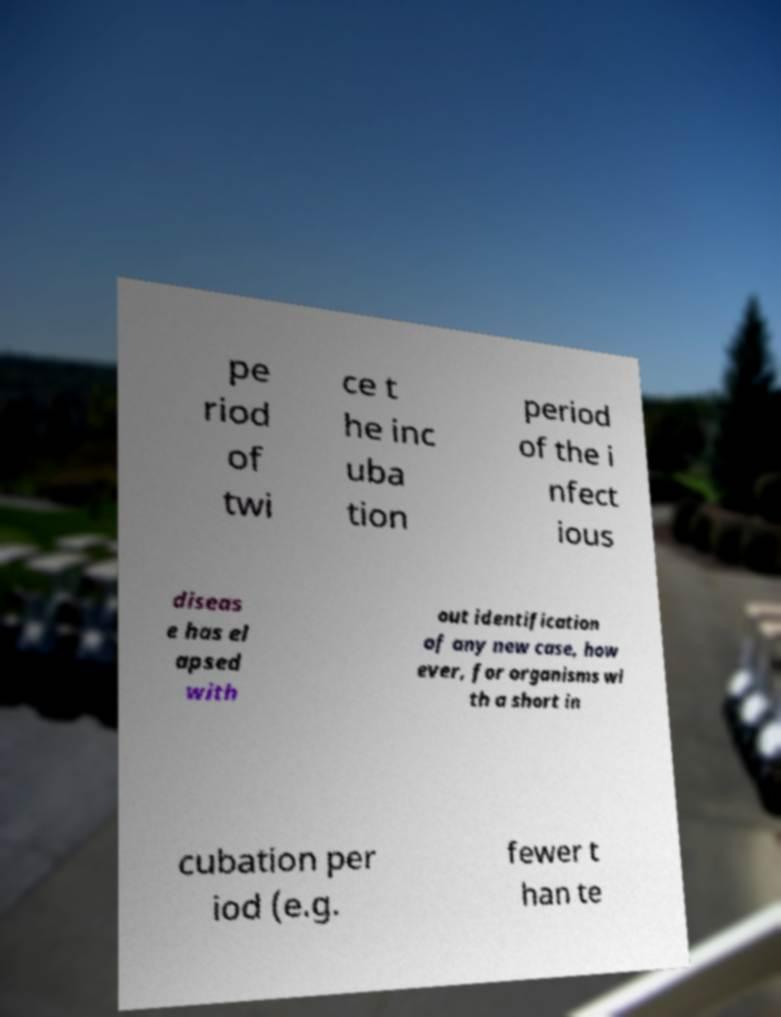There's text embedded in this image that I need extracted. Can you transcribe it verbatim? pe riod of twi ce t he inc uba tion period of the i nfect ious diseas e has el apsed with out identification of any new case, how ever, for organisms wi th a short in cubation per iod (e.g. fewer t han te 